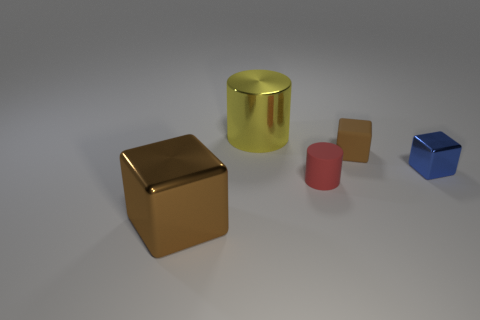Is the yellow cylinder made of the same material as the brown object behind the big shiny cube?
Your response must be concise. No. Are there more cylinders that are right of the tiny metal block than tiny brown matte cubes that are on the left side of the large metallic cube?
Offer a very short reply. No. There is a tiny shiny object; what shape is it?
Offer a very short reply. Cube. Are the tiny red thing in front of the small blue block and the cube behind the tiny blue object made of the same material?
Your answer should be very brief. Yes. The big metal thing in front of the large yellow cylinder has what shape?
Give a very brief answer. Cube. What is the size of the rubber object that is the same shape as the yellow shiny thing?
Ensure brevity in your answer.  Small. Is the color of the big cylinder the same as the small shiny block?
Ensure brevity in your answer.  No. Are there any other things that are the same shape as the small metal thing?
Your answer should be very brief. Yes. There is a large object that is in front of the red matte cylinder; is there a large brown shiny cube behind it?
Your answer should be compact. No. The other shiny thing that is the same shape as the blue thing is what color?
Provide a succinct answer. Brown. 